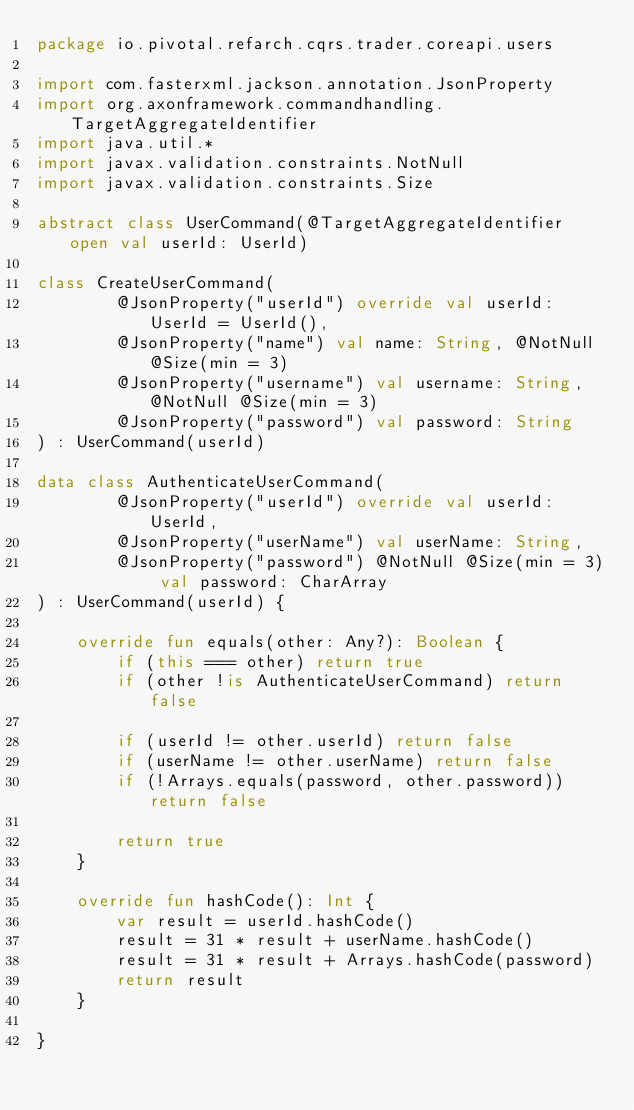Convert code to text. <code><loc_0><loc_0><loc_500><loc_500><_Kotlin_>package io.pivotal.refarch.cqrs.trader.coreapi.users

import com.fasterxml.jackson.annotation.JsonProperty
import org.axonframework.commandhandling.TargetAggregateIdentifier
import java.util.*
import javax.validation.constraints.NotNull
import javax.validation.constraints.Size

abstract class UserCommand(@TargetAggregateIdentifier open val userId: UserId)

class CreateUserCommand(
        @JsonProperty("userId") override val userId: UserId = UserId(),
        @JsonProperty("name") val name: String, @NotNull @Size(min = 3)
        @JsonProperty("username") val username: String, @NotNull @Size(min = 3)
        @JsonProperty("password") val password: String
) : UserCommand(userId)

data class AuthenticateUserCommand(
        @JsonProperty("userId") override val userId: UserId,
        @JsonProperty("userName") val userName: String,
        @JsonProperty("password") @NotNull @Size(min = 3) val password: CharArray
) : UserCommand(userId) {

    override fun equals(other: Any?): Boolean {
        if (this === other) return true
        if (other !is AuthenticateUserCommand) return false

        if (userId != other.userId) return false
        if (userName != other.userName) return false
        if (!Arrays.equals(password, other.password)) return false

        return true
    }

    override fun hashCode(): Int {
        var result = userId.hashCode()
        result = 31 * result + userName.hashCode()
        result = 31 * result + Arrays.hashCode(password)
        return result
    }

}
</code> 